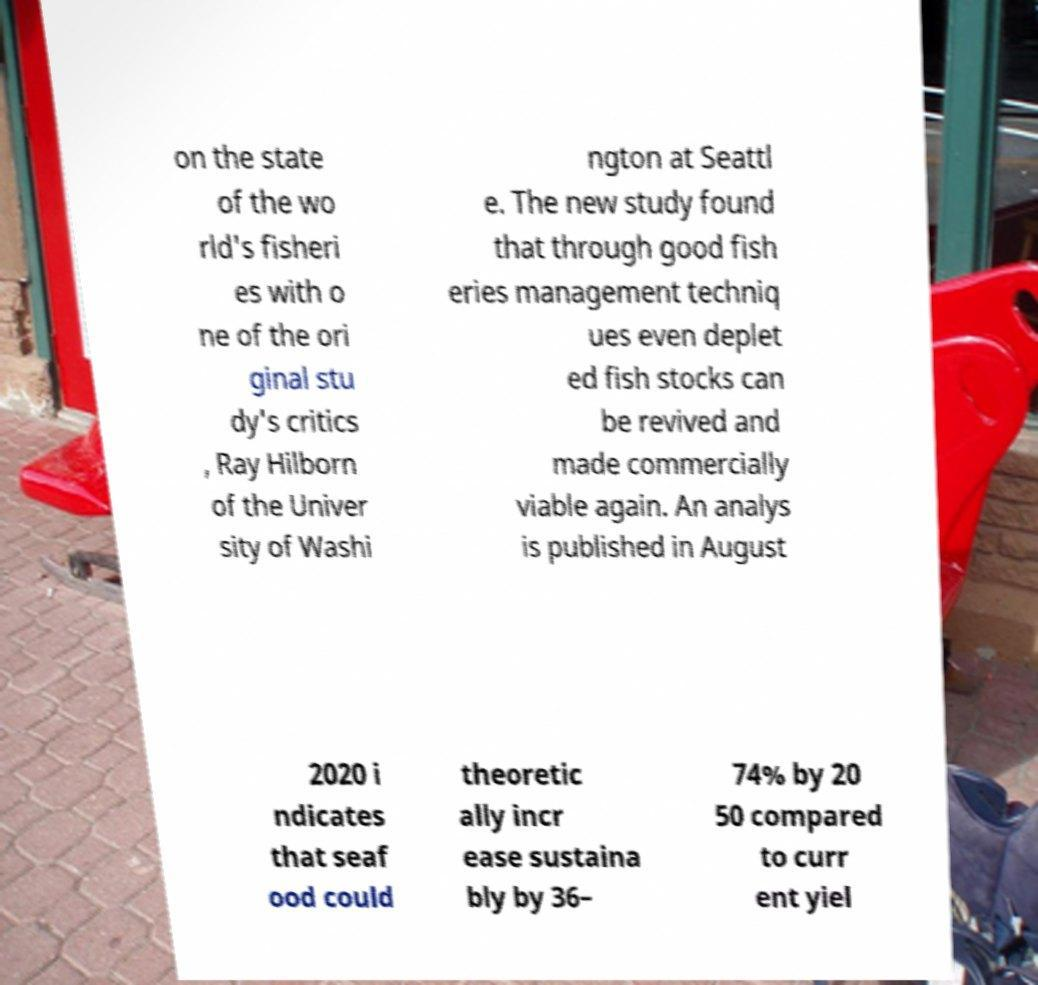Could you assist in decoding the text presented in this image and type it out clearly? on the state of the wo rld's fisheri es with o ne of the ori ginal stu dy's critics , Ray Hilborn of the Univer sity of Washi ngton at Seattl e. The new study found that through good fish eries management techniq ues even deplet ed fish stocks can be revived and made commercially viable again. An analys is published in August 2020 i ndicates that seaf ood could theoretic ally incr ease sustaina bly by 36– 74% by 20 50 compared to curr ent yiel 